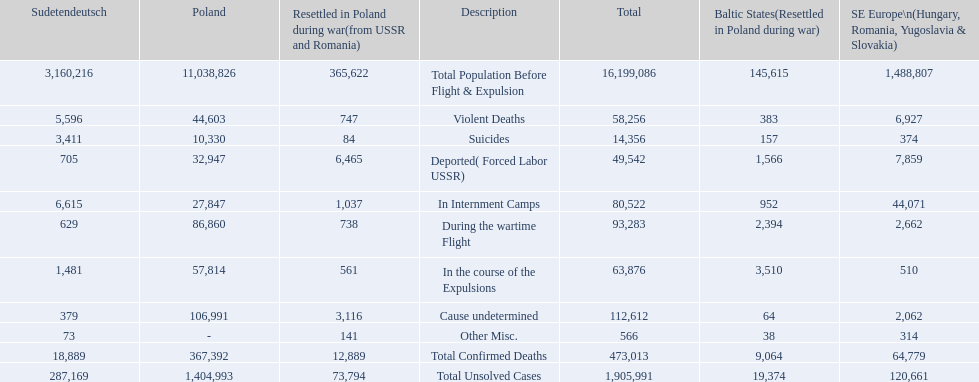What are the numbers of violent deaths across the area? 44,603, 383, 747, 5,596, 6,927. What is the total number of violent deaths of the area? 58,256. 